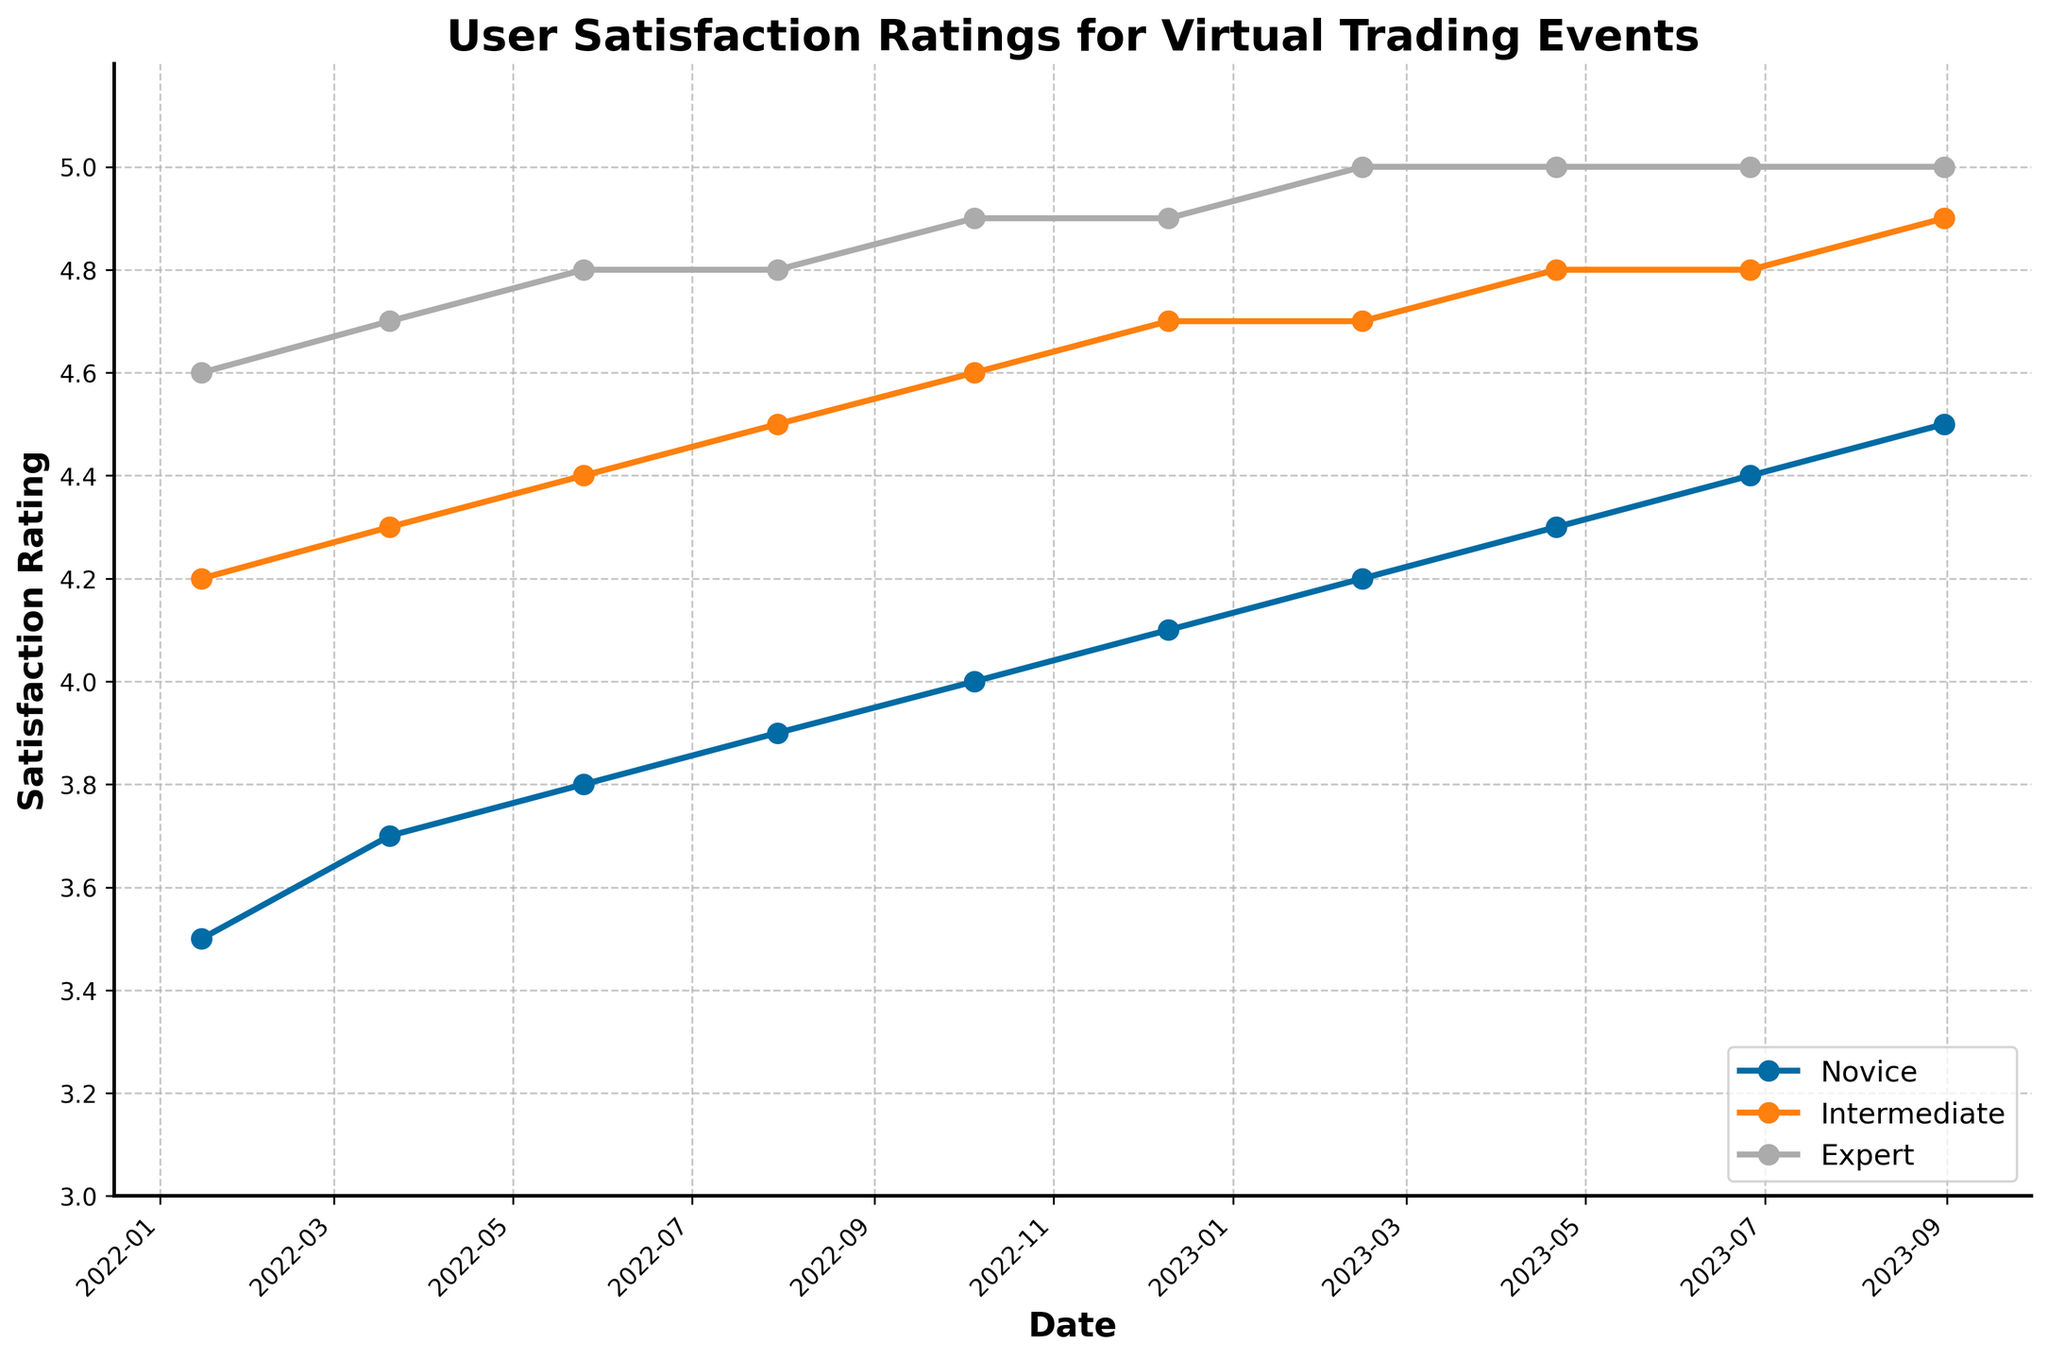What's the user satisfaction rating trend for novice participants from January 2022 to August 2023? The novice participants' satisfaction rating increased steadily from 3.5 in January 2022 to 4.5 in August 2023.
Answer: Increased from 3.5 to 4.5 Which participant experience level consistently has the highest satisfaction rating over the entire period? By observing the plotted lines, the expert participants consistently have the highest satisfaction ratings across all dates, culminating in a rating of 5.0 from February 2023 onwards.
Answer: Expert Is there a point at which the satisfaction rating is equal for novice and intermediate participants? Analyzing the plotted lines, there is no point where the satisfaction ratings for novice and intermediate participants are equal. The novice ratings always stay below the intermediate ratings.
Answer: No How does the satisfaction rating gap between novice and expert participants change from January 2022 to August 2023? The gap between novice and expert starts at 1.1 (4.6 - 3.5) in January 2022 and narrows down to 0.5 (5.0 - 4.5) by August 2023. The gap consistently narrows over time.
Answer: Narrows from 1.1 to 0.5 What is the overall trend observed for intermediate participants' satisfaction ratings from January 2022 to August 2023? The intermediate participants' satisfaction ratings show an upward trend starting from 4.2 in January 2022 and reaching 4.9 by August 2023, indicating a consistent increase over time.
Answer: Upward trend from 4.2 to 4.9 When did novice participants first reach a satisfaction rating of 4.0 or higher? The novice participants first reached a satisfaction rating of 4.0 in October 2022. This can be seen where the plotted line crosses the 4.0 mark.
Answer: October 2022 Compare the rate of increase in satisfaction ratings for novice and expert participants from January 2022 to August 2023. The novice participants' ratings increased by 1.0 points (from 3.5 to 4.5), while the expert participants' ratings increased by 0.4 points (from 4.6 to 5.0) over the same period. Thus, the novice participants' ratings increased at a faster rate.
Answer: Novice increased faster (1.0 vs 0.4) What's the difference in satisfaction ratings between intermediate and expert participants in August 2023? In August 2023, the satisfaction rating for intermediate participants is 4.9, while for expert participants, it is 5.0. Thus, the difference is 0.1 points.
Answer: 0.1 points Which segment shows no change in satisfaction ratings after February 2023? Examining the plotted lines, the expert participants show no change after February 2023, consistently maintaining a rating of 5.0 from that point onwards.
Answer: Expert 